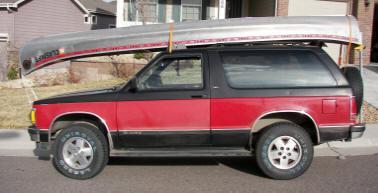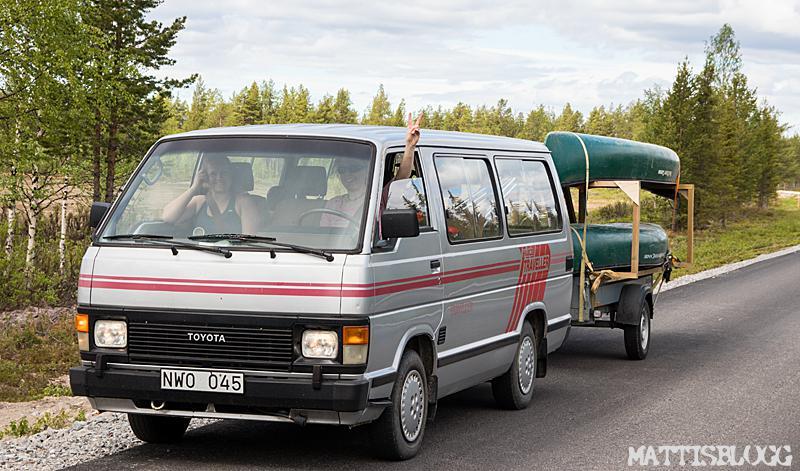The first image is the image on the left, the second image is the image on the right. For the images displayed, is the sentence "All vehicles have a single boat secured to the roof." factually correct? Answer yes or no. No. 